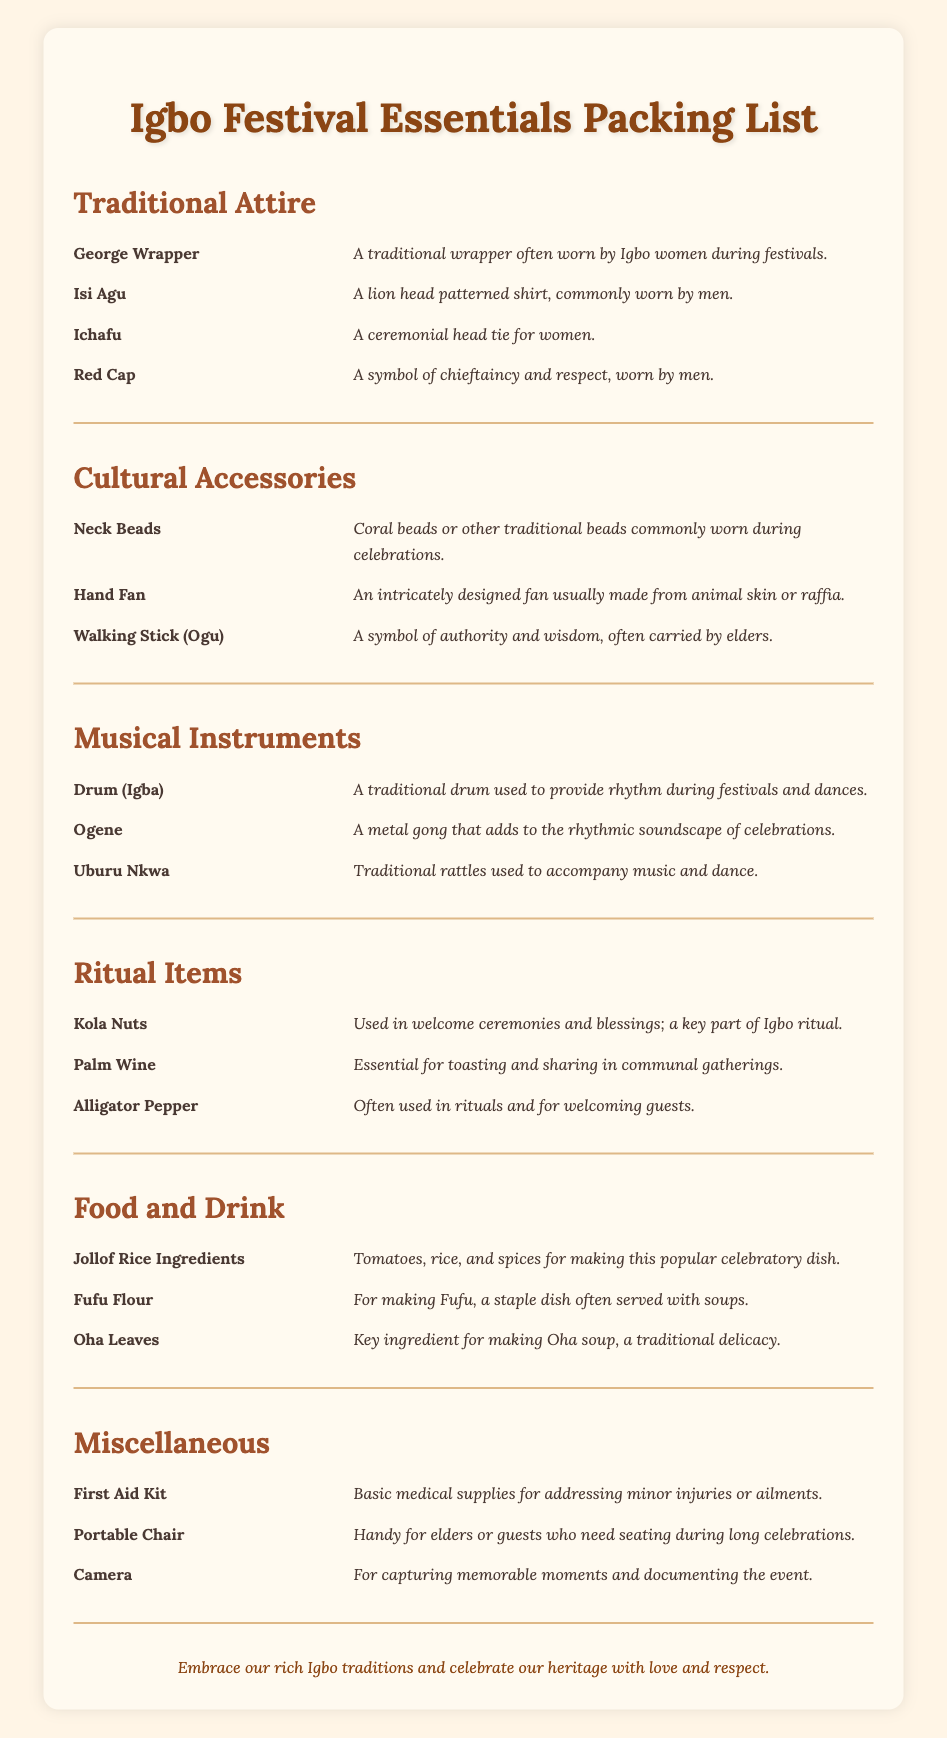What are the items listed under Traditional Attire? The items listed include George Wrapper, Isi Agu, Ichafu, and Red Cap.
Answer: George Wrapper, Isi Agu, Ichafu, Red Cap What is the cultural significance of Kola Nuts? Kola Nuts are used in welcome ceremonies and blessings; they are a key part of Igbo ritual.
Answer: Welcome ceremonies and blessings Which musical instrument is a traditional drum? The traditional drum used to provide rhythm during festivals is called Igba.
Answer: Igba What is the main ingredient for making Oha soup? Oha soup requires Oha Leaves as a key ingredient.
Answer: Oha Leaves What type of items are included in the Miscellaneous section? The Miscellaneous section includes a First Aid Kit, Portable Chair, and Camera.
Answer: First Aid Kit, Portable Chair, Camera How many items are listed under Cultural Accessories? There are three items listed under Cultural Accessories: Neck Beads, Hand Fan, and Walking Stick.
Answer: Three What is the purpose of the Red Cap in Igbo culture? The Red Cap is a symbol of chieftaincy and respect, worn by men.
Answer: Chieftaincy and respect Which item is essential for toasting in communal gatherings? Palm Wine is essential for toasting and sharing in communal gatherings.
Answer: Palm Wine What type of chair is mentioned for seating during long celebrations? The document mentions a Portable Chair for seating during long celebrations.
Answer: Portable Chair 